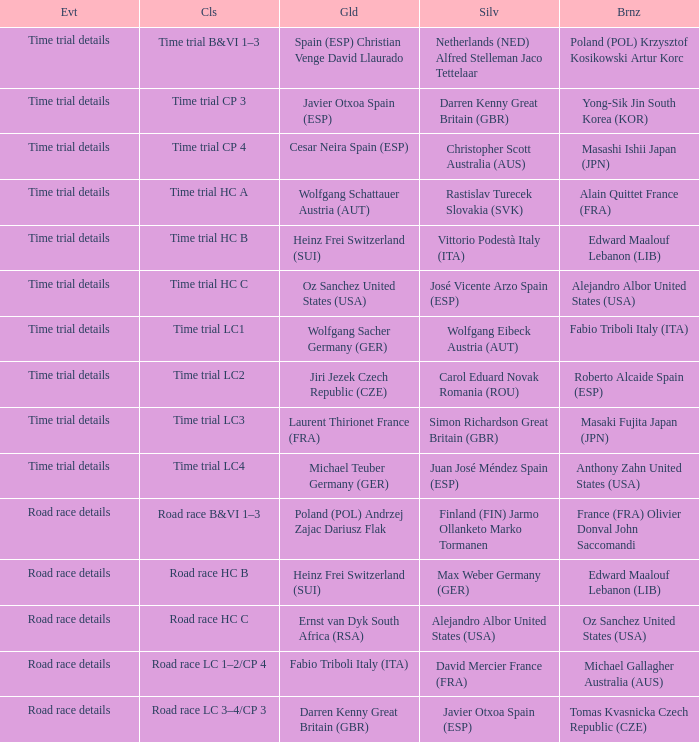What is the event when the class is time trial hc a? Time trial details. 